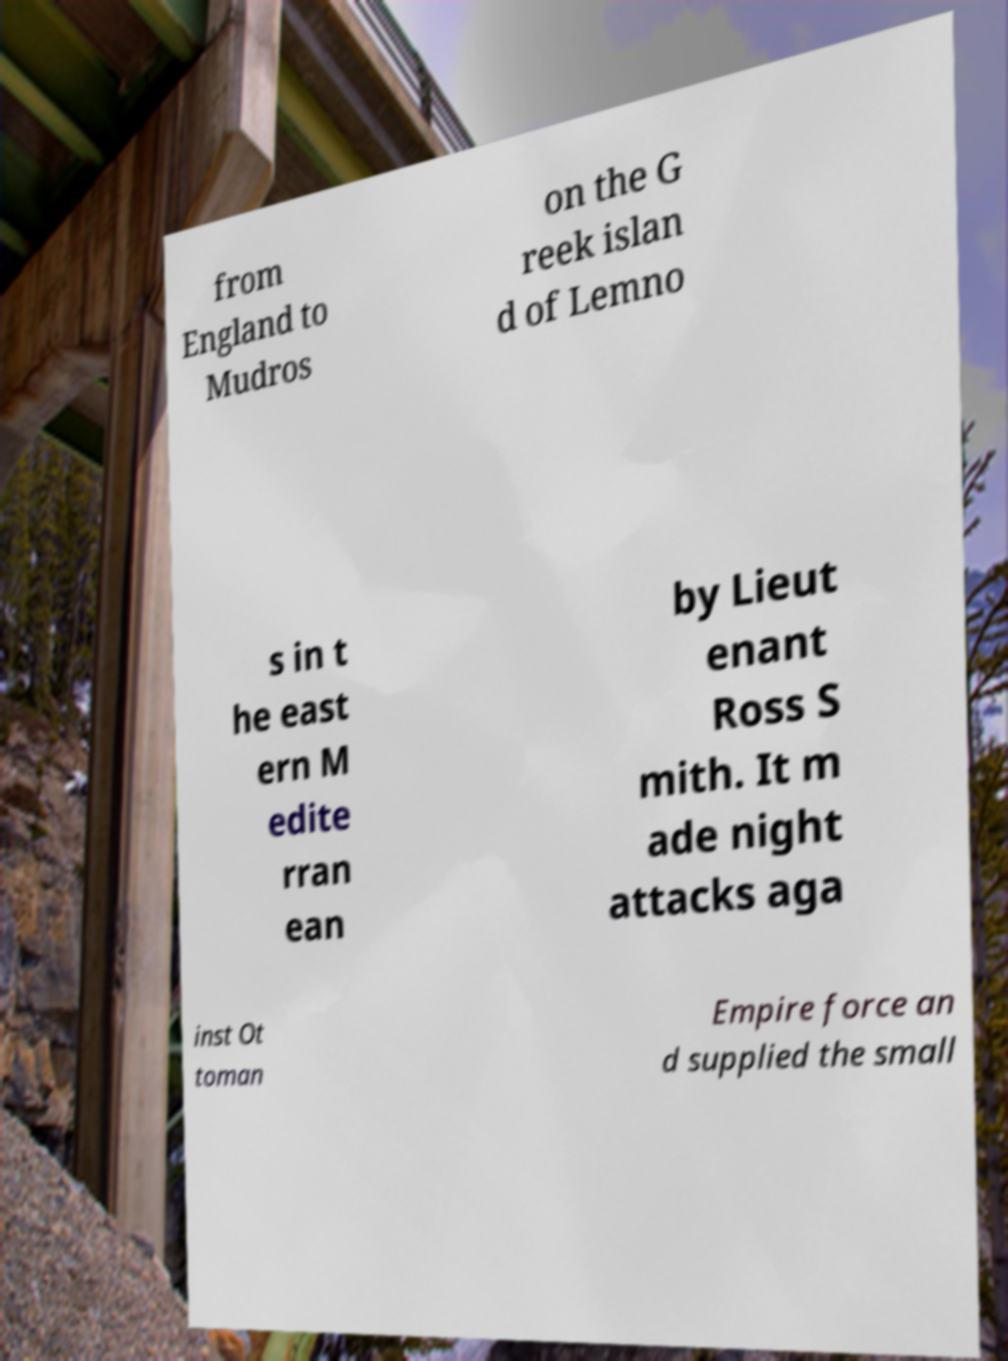Could you extract and type out the text from this image? from England to Mudros on the G reek islan d of Lemno s in t he east ern M edite rran ean by Lieut enant Ross S mith. It m ade night attacks aga inst Ot toman Empire force an d supplied the small 